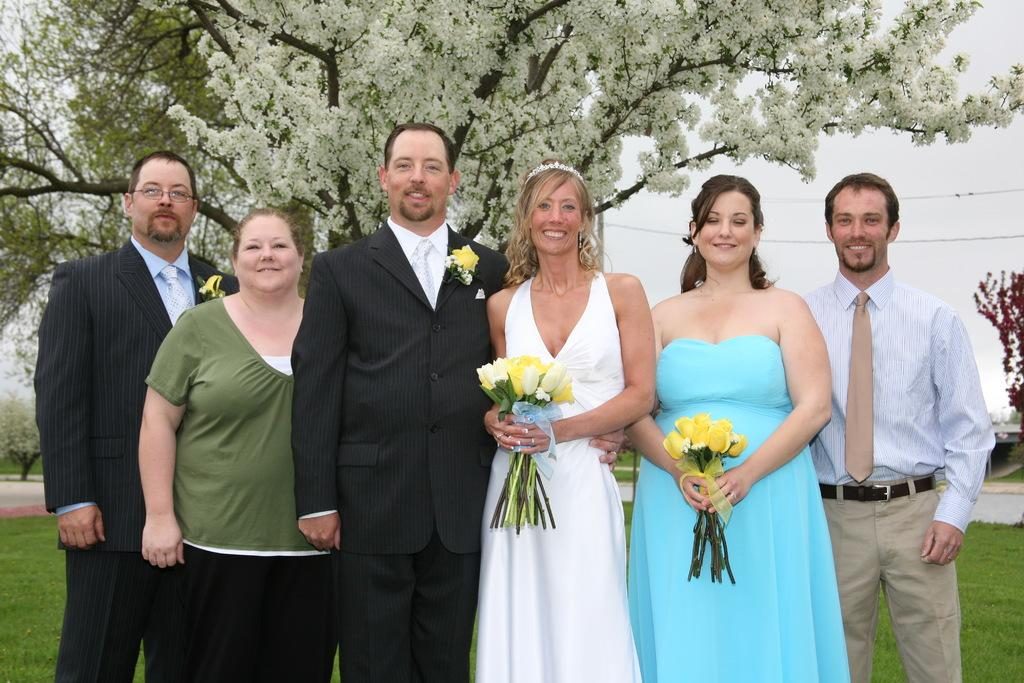How many persons are in the image? There are persons in the image. What other elements can be seen in the image besides the persons? There are flowers and other objects in the image. What can be seen in the background of the image? There are trees, cables, and the sky visible in the background of the image. Are there any other objects in the background of the image? Yes, there are other objects in the background of the image. What type of insurance policy do the persons in the image have? There is no information about insurance policies in the image. The image features persons, flowers, and other objects, with a background that includes trees, cables, and the sky. 